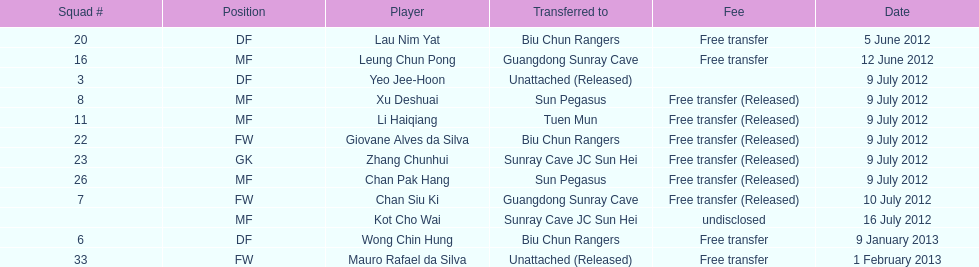What's the overall count of players transferred to sun pegasus? 2. 